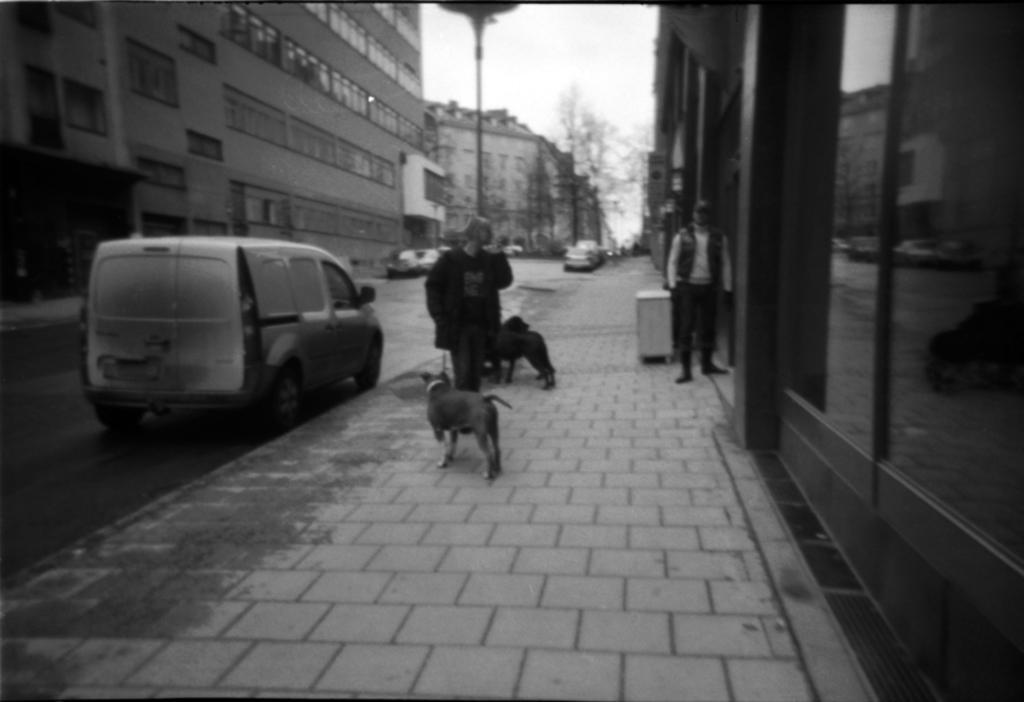Please provide a concise description of this image. In this picture we can see vehicles on road and aside to this road there is foot path where two persons are standing on it and two dogs and in background we can see building with windows, trees. 